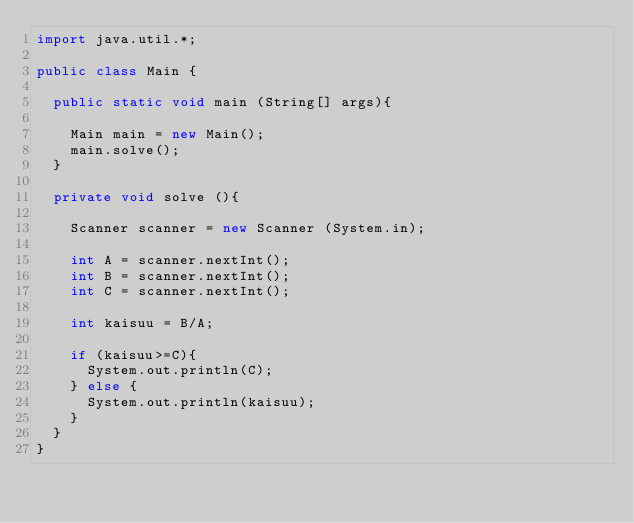<code> <loc_0><loc_0><loc_500><loc_500><_Java_>import java.util.*;

public class Main {
  
  public static void main (String[] args){
    
    Main main = new Main();
    main.solve();
  }
  
  private void solve (){
    
    Scanner scanner = new Scanner (System.in);
    
    int A = scanner.nextInt();
    int B = scanner.nextInt();
    int C = scanner.nextInt();
    
    int kaisuu = B/A;
    
    if (kaisuu>=C){
      System.out.println(C);
    } else {
      System.out.println(kaisuu);
    }
  }
}</code> 